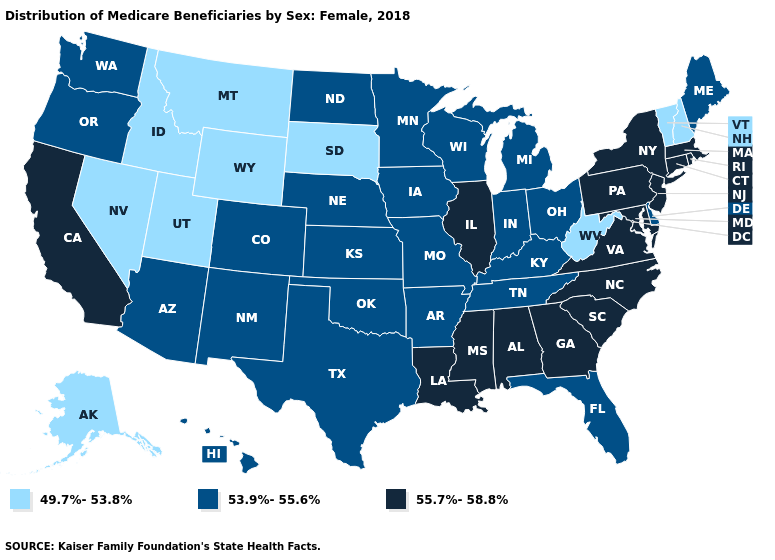What is the value of Wisconsin?
Be succinct. 53.9%-55.6%. What is the highest value in the West ?
Give a very brief answer. 55.7%-58.8%. What is the value of Missouri?
Short answer required. 53.9%-55.6%. Does New Jersey have the highest value in the USA?
Concise answer only. Yes. Does the map have missing data?
Concise answer only. No. What is the value of Alaska?
Keep it brief. 49.7%-53.8%. What is the value of Idaho?
Write a very short answer. 49.7%-53.8%. What is the value of Louisiana?
Be succinct. 55.7%-58.8%. Does New York have the lowest value in the Northeast?
Give a very brief answer. No. Which states hav the highest value in the South?
Short answer required. Alabama, Georgia, Louisiana, Maryland, Mississippi, North Carolina, South Carolina, Virginia. Does Delaware have the highest value in the South?
Be succinct. No. Among the states that border Missouri , does Oklahoma have the highest value?
Answer briefly. No. What is the lowest value in states that border Oregon?
Keep it brief. 49.7%-53.8%. What is the value of Georgia?
Give a very brief answer. 55.7%-58.8%. Name the states that have a value in the range 49.7%-53.8%?
Answer briefly. Alaska, Idaho, Montana, Nevada, New Hampshire, South Dakota, Utah, Vermont, West Virginia, Wyoming. 